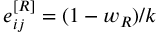Convert formula to latex. <formula><loc_0><loc_0><loc_500><loc_500>e _ { i j } ^ { [ R ] } = ( 1 - w _ { R } ) / k</formula> 